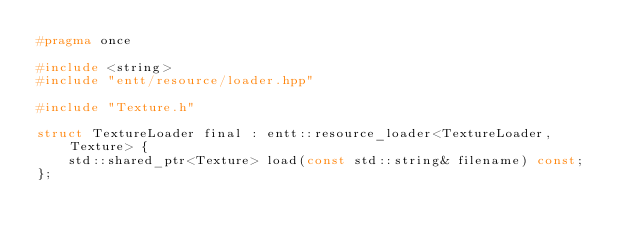Convert code to text. <code><loc_0><loc_0><loc_500><loc_500><_C_>#pragma once

#include <string>
#include "entt/resource/loader.hpp"

#include "Texture.h"

struct TextureLoader final : entt::resource_loader<TextureLoader, Texture> {
	std::shared_ptr<Texture> load(const std::string& filename) const;
};</code> 